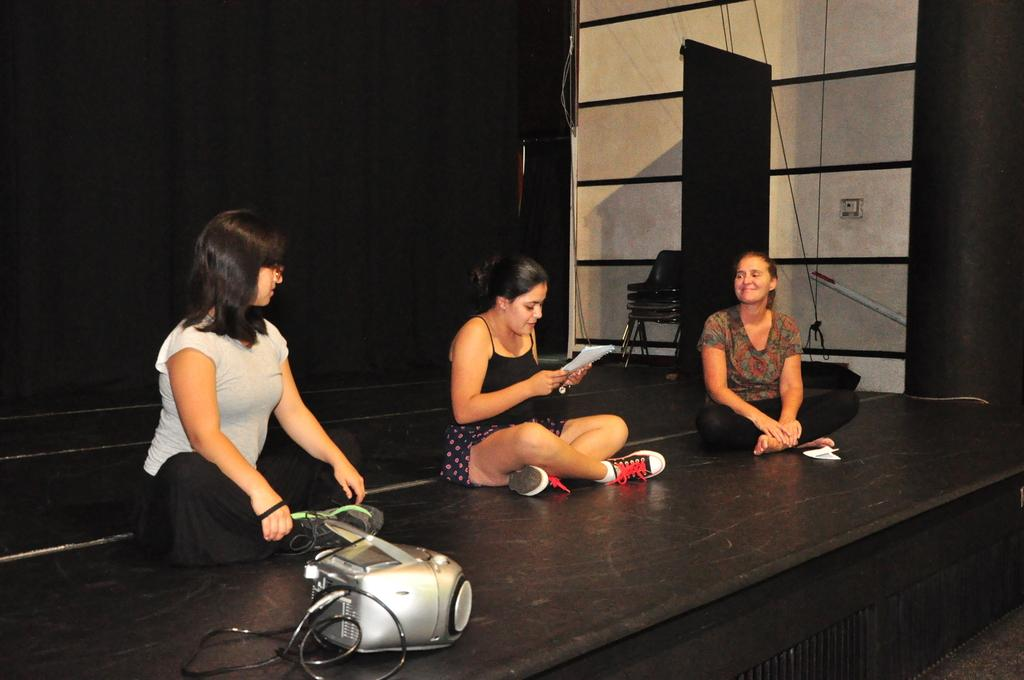What are the women in the image doing? The women are sitting on the dais in the image. What can be seen at the bottom of the image? There is a projector at the bottom of the image. What is visible in the background of the image? There is a wall, a switch board, and curtains in the background of the image. Can you see any kites flying in the image? There are no kites visible in the image. What type of farm is present in the image? There is no farm present in the image. 